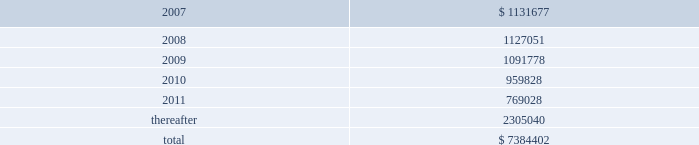American tower corporation and subsidiaries notes to consolidated financial statements 2014 ( continued ) future minimum rental receipts expected from customers under non-cancelable operating lease agreements in effect at december 31 , 2006 are as follows ( in thousands ) : year ending december 31 .
Legal and governmental proceedings related to review of stock option granting practices and related accounting 2014on may 18 , 2006 , the company received a letter of informal inquiry from the sec division of enforcement requesting documents related to company stock option grants and stock option practices .
The inquiry is focused on stock options granted to senior management and members of the company 2019s board of directors during the period 1997 to the present .
The company continues to cooperate with the sec to provide the requested information and documents .
On may 19 , 2006 , the company received a subpoena from the united states attorney 2019s office for the eastern district of new york for records and information relating to its stock option granting practices .
The subpoena requests materials related to certain stock options granted between 1995 and the present .
The company continues to cooperate with the u.s .
Attorney 2019s office to provide the requested information and documents .
On may 26 , 2006 , a securities class action was filed in united states district court for the district of massachusetts against the company and certain of its current officers by john s .
Greenebaum for monetary relief .
Specifically , the complaint names the company , james d .
Taiclet , jr .
And bradley e .
Singer as defendants and alleges that the defendants violated federal securities laws in connection with public statements made relating to the company 2019s stock option practices and related accounting .
The complaint asserts claims under sections 10 ( b ) and 20 ( a ) of the securities exchange act of 1934 , as amended ( exchange act ) and sec rule 10b-5 .
In december 2006 , the court appointed the steamship trade association-international longshoreman 2019s association pension fund as the lead plaintiff .
On may 24 , 2006 and june 14 , 2006 , two shareholder derivative lawsuits were filed in suffolk county superior court in massachusetts by eric johnston and robert l .
Garber , respectively .
The lawsuits were filed against certain of the company 2019s current and former officers and directors for alleged breaches of fiduciary duties and unjust enrichment in connection with the company 2019s stock option granting practices .
The lawsuits also name the company as a nominal defendant .
The lawsuits seek to recover the damages sustained by the company and disgorgement of all profits received with respect to the alleged backdated stock options .
In october 2006 , these two lawsuits were consolidated and transferred to the court 2019s business litigation session .
On june 13 , 2006 , june 22 , 2006 and august 23 , 2006 , three shareholder derivative lawsuits were filed in united states district court for the district of massachusetts by new south wales treasury corporation , as trustee for the alpha international managers trust , frank c .
Kalil and don holland , and leslie cramer , respectively .
The lawsuits were filed against certain of the company 2019s current and former officers and directors for alleged breaches of fiduciary duties , waste of corporate assets , gross mismanagement and unjust enrichment in connection with the company 2019s stock option granting practices .
The lawsuits also name the company as a nominal defendant .
In december 2006 , the court consolidated these three lawsuits and appointed new south wales treasury corporation as the lead plaintiff .
On february 9 , 2007 , the plaintiffs filed a consolidated .
What portion of the total future minimum rental receipts is expected to be collected in the next 12 months? 
Computations: (1131677 / 7384402)
Answer: 0.15325. 